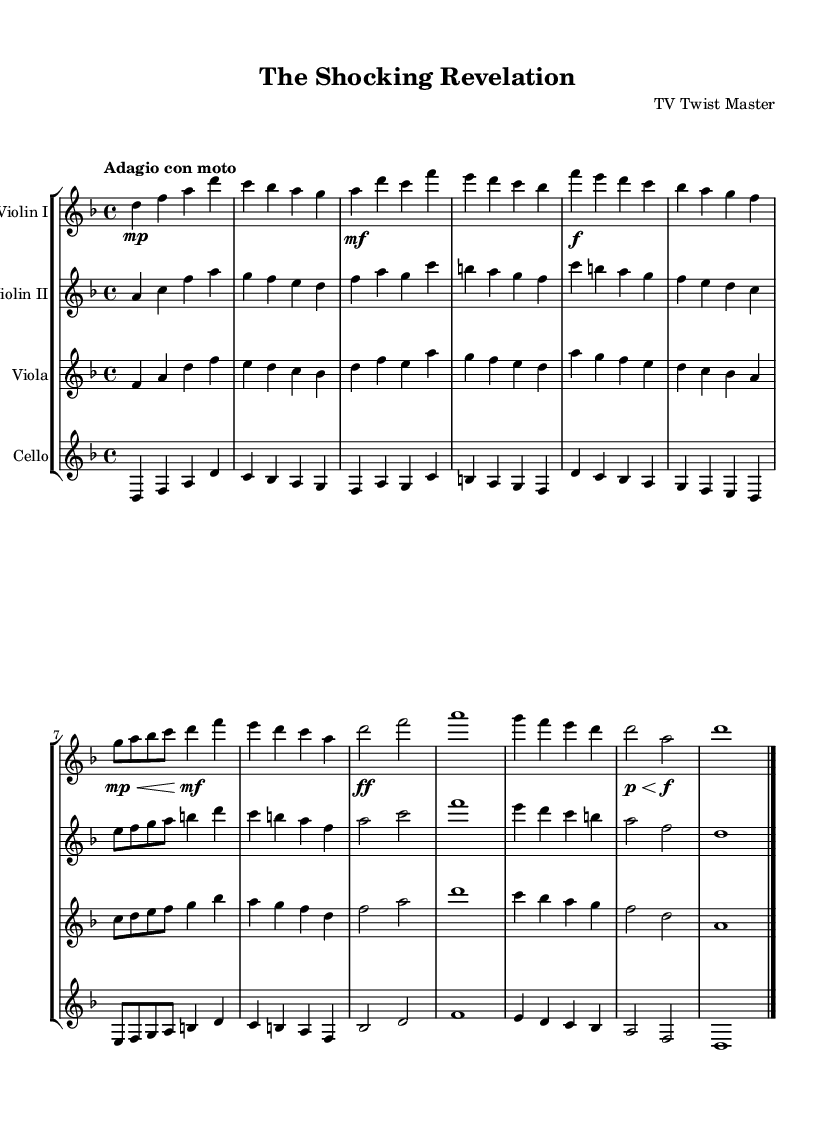What is the key signature of this music? The key signature is indicated at the beginning of the score. It shows a key signature of D minor, which has one flat (B flat).
Answer: D minor What is the time signature of this piece? The time signature is also displayed at the beginning of the score. It is 4/4, indicating that there are four beats in each measure, and the quarter note gets one beat.
Answer: 4/4 What tempo marking is indicated in the score? The tempo is specified in the score. It states "Adagio con moto," which indicates a slow tempo with some motion.
Answer: Adagio con moto How many distinct themes are presented in the piece? The score contains two main themes labeled as Theme A and Theme B. Each theme has unique melodic material presented throughout the piece.
Answer: Two What is the dynamics marking for the climax section? The climax section is indicated with a dynamic marking of ff (fortissimo), suggesting a strong and powerful sound.
Answer: Fortissimo What is the highest note written for the Violin I line? The Violin I part reaches the highest note during the Climax section, where the note A appears after a series of ascending pitches.
Answer: A During the Coda, how long does the final note hold for Violin I? The final note in the Coda for Violin I is indicated as a whole note, which is held for the entire measure.
Answer: Whole note 